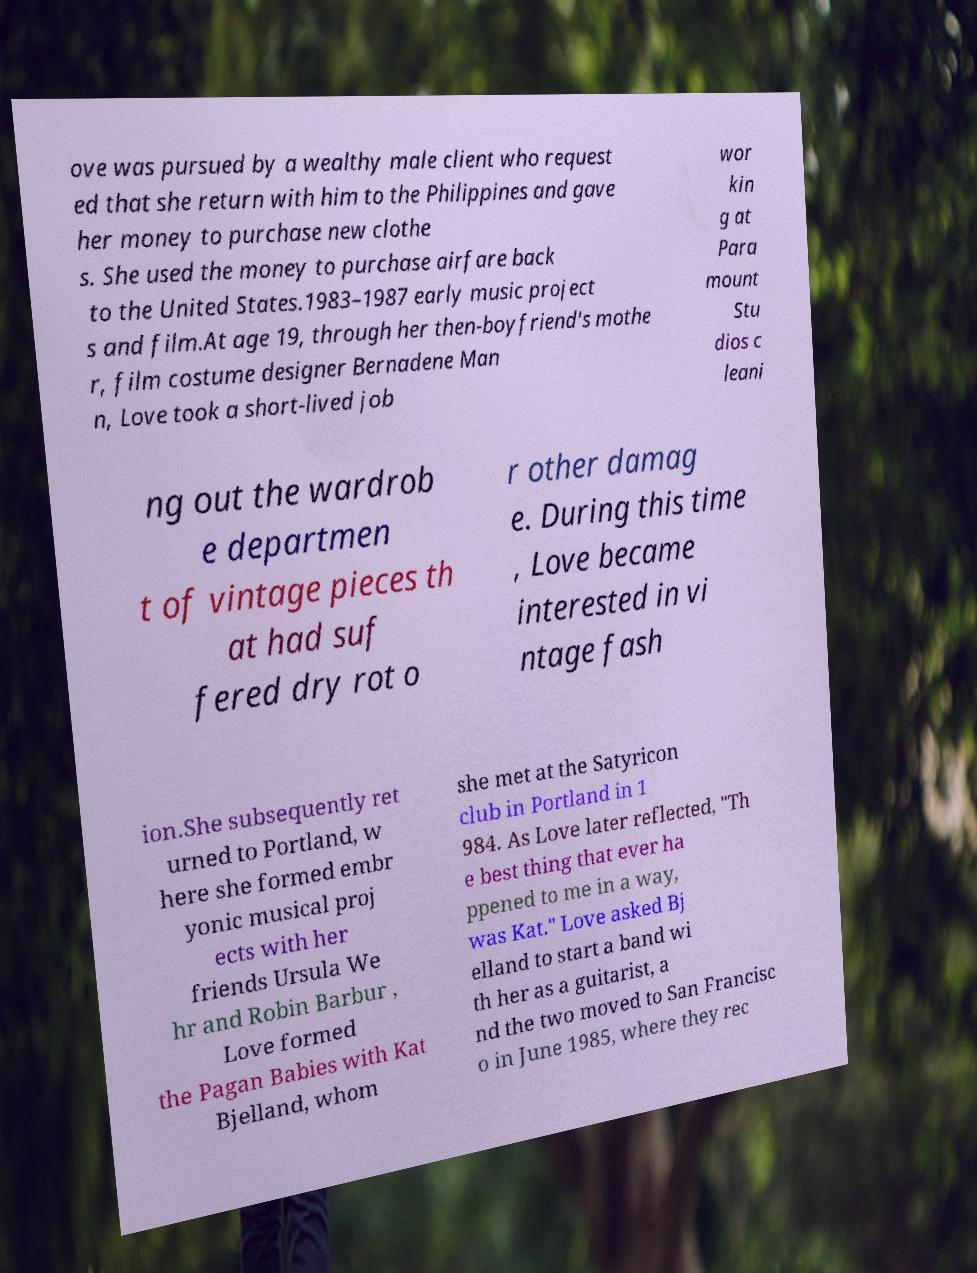Can you read and provide the text displayed in the image?This photo seems to have some interesting text. Can you extract and type it out for me? ove was pursued by a wealthy male client who request ed that she return with him to the Philippines and gave her money to purchase new clothe s. She used the money to purchase airfare back to the United States.1983–1987 early music project s and film.At age 19, through her then-boyfriend's mothe r, film costume designer Bernadene Man n, Love took a short-lived job wor kin g at Para mount Stu dios c leani ng out the wardrob e departmen t of vintage pieces th at had suf fered dry rot o r other damag e. During this time , Love became interested in vi ntage fash ion.She subsequently ret urned to Portland, w here she formed embr yonic musical proj ects with her friends Ursula We hr and Robin Barbur , Love formed the Pagan Babies with Kat Bjelland, whom she met at the Satyricon club in Portland in 1 984. As Love later reflected, "Th e best thing that ever ha ppened to me in a way, was Kat." Love asked Bj elland to start a band wi th her as a guitarist, a nd the two moved to San Francisc o in June 1985, where they rec 